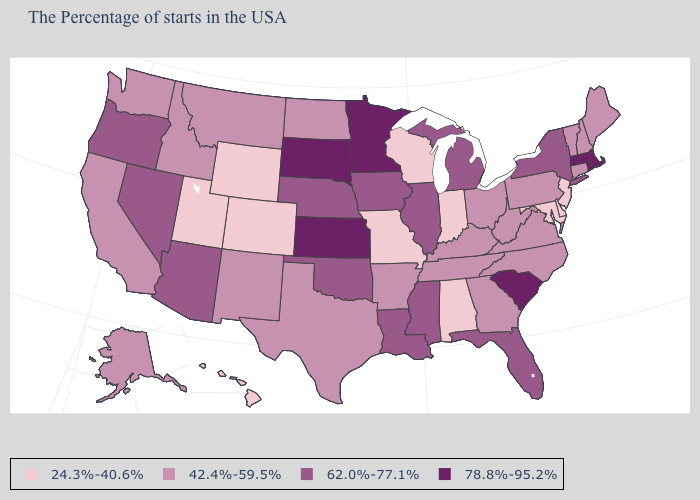Does Illinois have the lowest value in the USA?
Answer briefly. No. Name the states that have a value in the range 24.3%-40.6%?
Give a very brief answer. New Jersey, Delaware, Maryland, Indiana, Alabama, Wisconsin, Missouri, Wyoming, Colorado, Utah, Hawaii. What is the value of Colorado?
Write a very short answer. 24.3%-40.6%. What is the value of Tennessee?
Short answer required. 42.4%-59.5%. Which states have the lowest value in the USA?
Be succinct. New Jersey, Delaware, Maryland, Indiana, Alabama, Wisconsin, Missouri, Wyoming, Colorado, Utah, Hawaii. Among the states that border Indiana , which have the lowest value?
Give a very brief answer. Ohio, Kentucky. Among the states that border Georgia , which have the highest value?
Write a very short answer. South Carolina. Among the states that border New Hampshire , does Massachusetts have the lowest value?
Be succinct. No. Is the legend a continuous bar?
Quick response, please. No. What is the value of Utah?
Answer briefly. 24.3%-40.6%. What is the value of Oregon?
Be succinct. 62.0%-77.1%. Name the states that have a value in the range 24.3%-40.6%?
Be succinct. New Jersey, Delaware, Maryland, Indiana, Alabama, Wisconsin, Missouri, Wyoming, Colorado, Utah, Hawaii. Among the states that border Wisconsin , which have the lowest value?
Concise answer only. Michigan, Illinois, Iowa. Does the first symbol in the legend represent the smallest category?
Quick response, please. Yes. Among the states that border Ohio , which have the lowest value?
Be succinct. Indiana. 